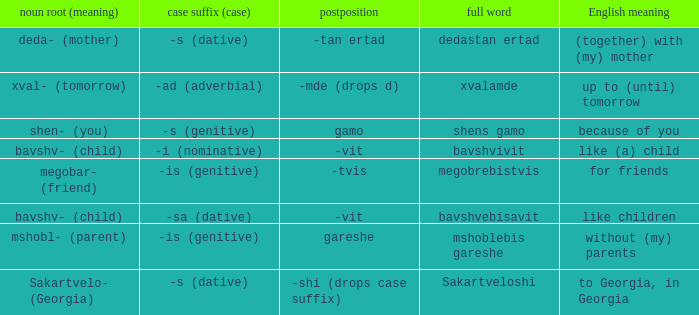What is Case Suffix (Case), when Postposition is "-mde (drops d)"? -ad (adverbial). 